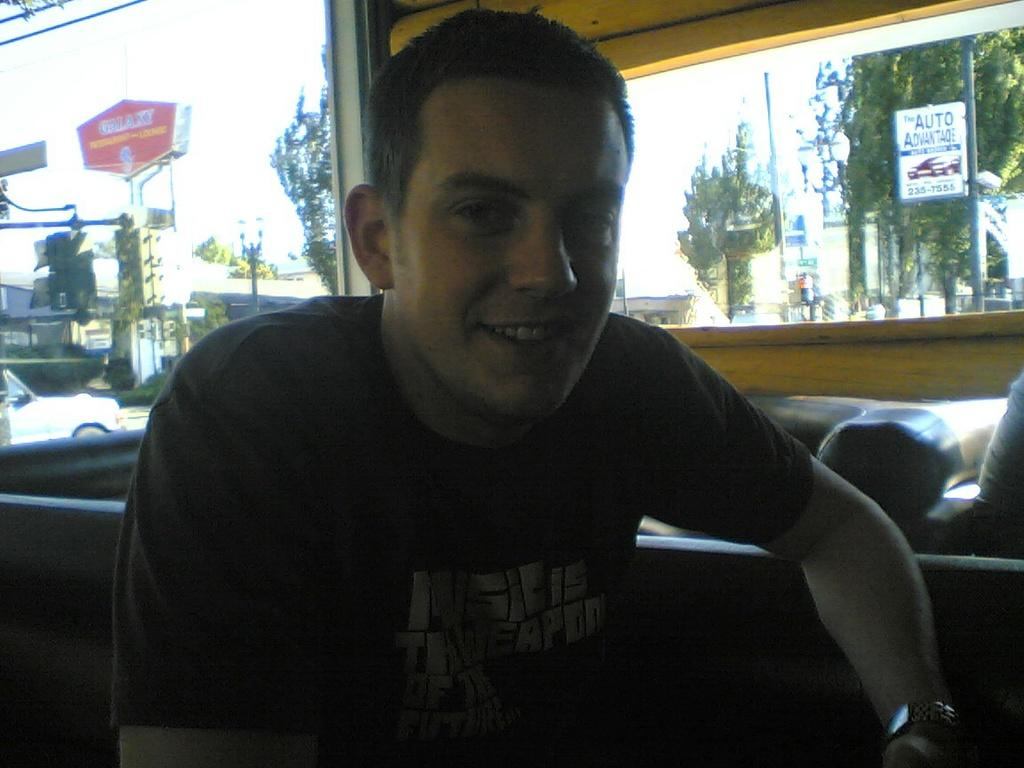Who is present in the image? There is a man in the image. What is the man's facial expression? The man is smiling. What can be seen in the background of the image? There are trees, poles, boards, vehicles, and the sky visible in the background of the image. What type of toothbrush is the man using in the image? There is no toothbrush present in the image. What is the man trying to copy in the image? There is no indication in the image that the man is trying to copy anything. 